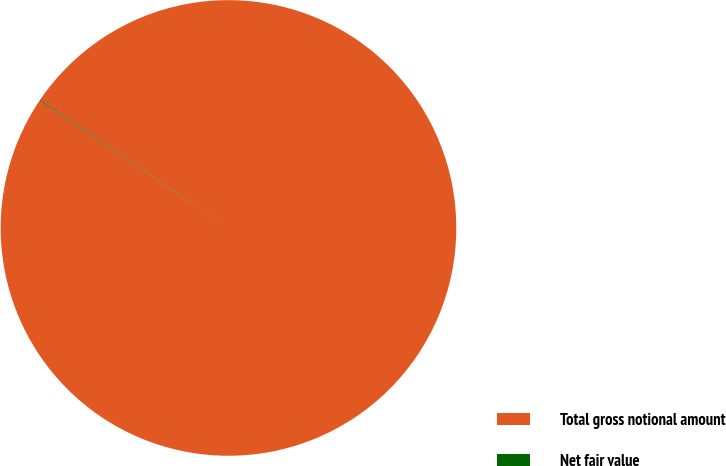<chart> <loc_0><loc_0><loc_500><loc_500><pie_chart><fcel>Total gross notional amount<fcel>Net fair value<nl><fcel>99.94%<fcel>0.06%<nl></chart> 